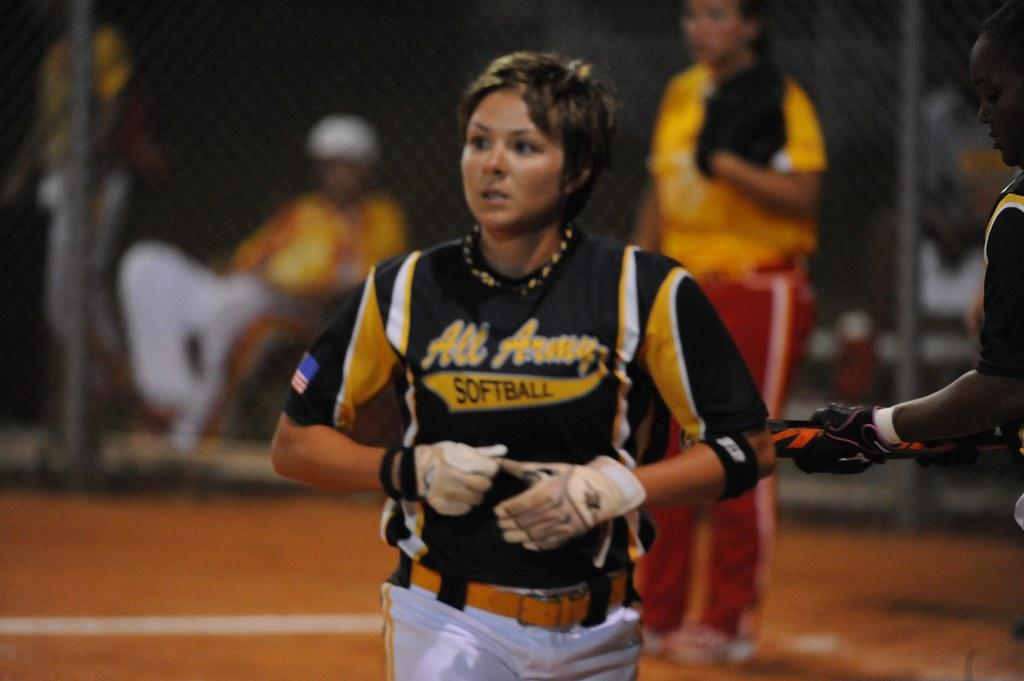<image>
Summarize the visual content of the image. A girl is wearing a jersey with the word softball on it. 